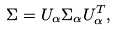<formula> <loc_0><loc_0><loc_500><loc_500>\Sigma = U _ { \alpha } \Sigma _ { \alpha } U _ { \alpha } ^ { T } ,</formula> 